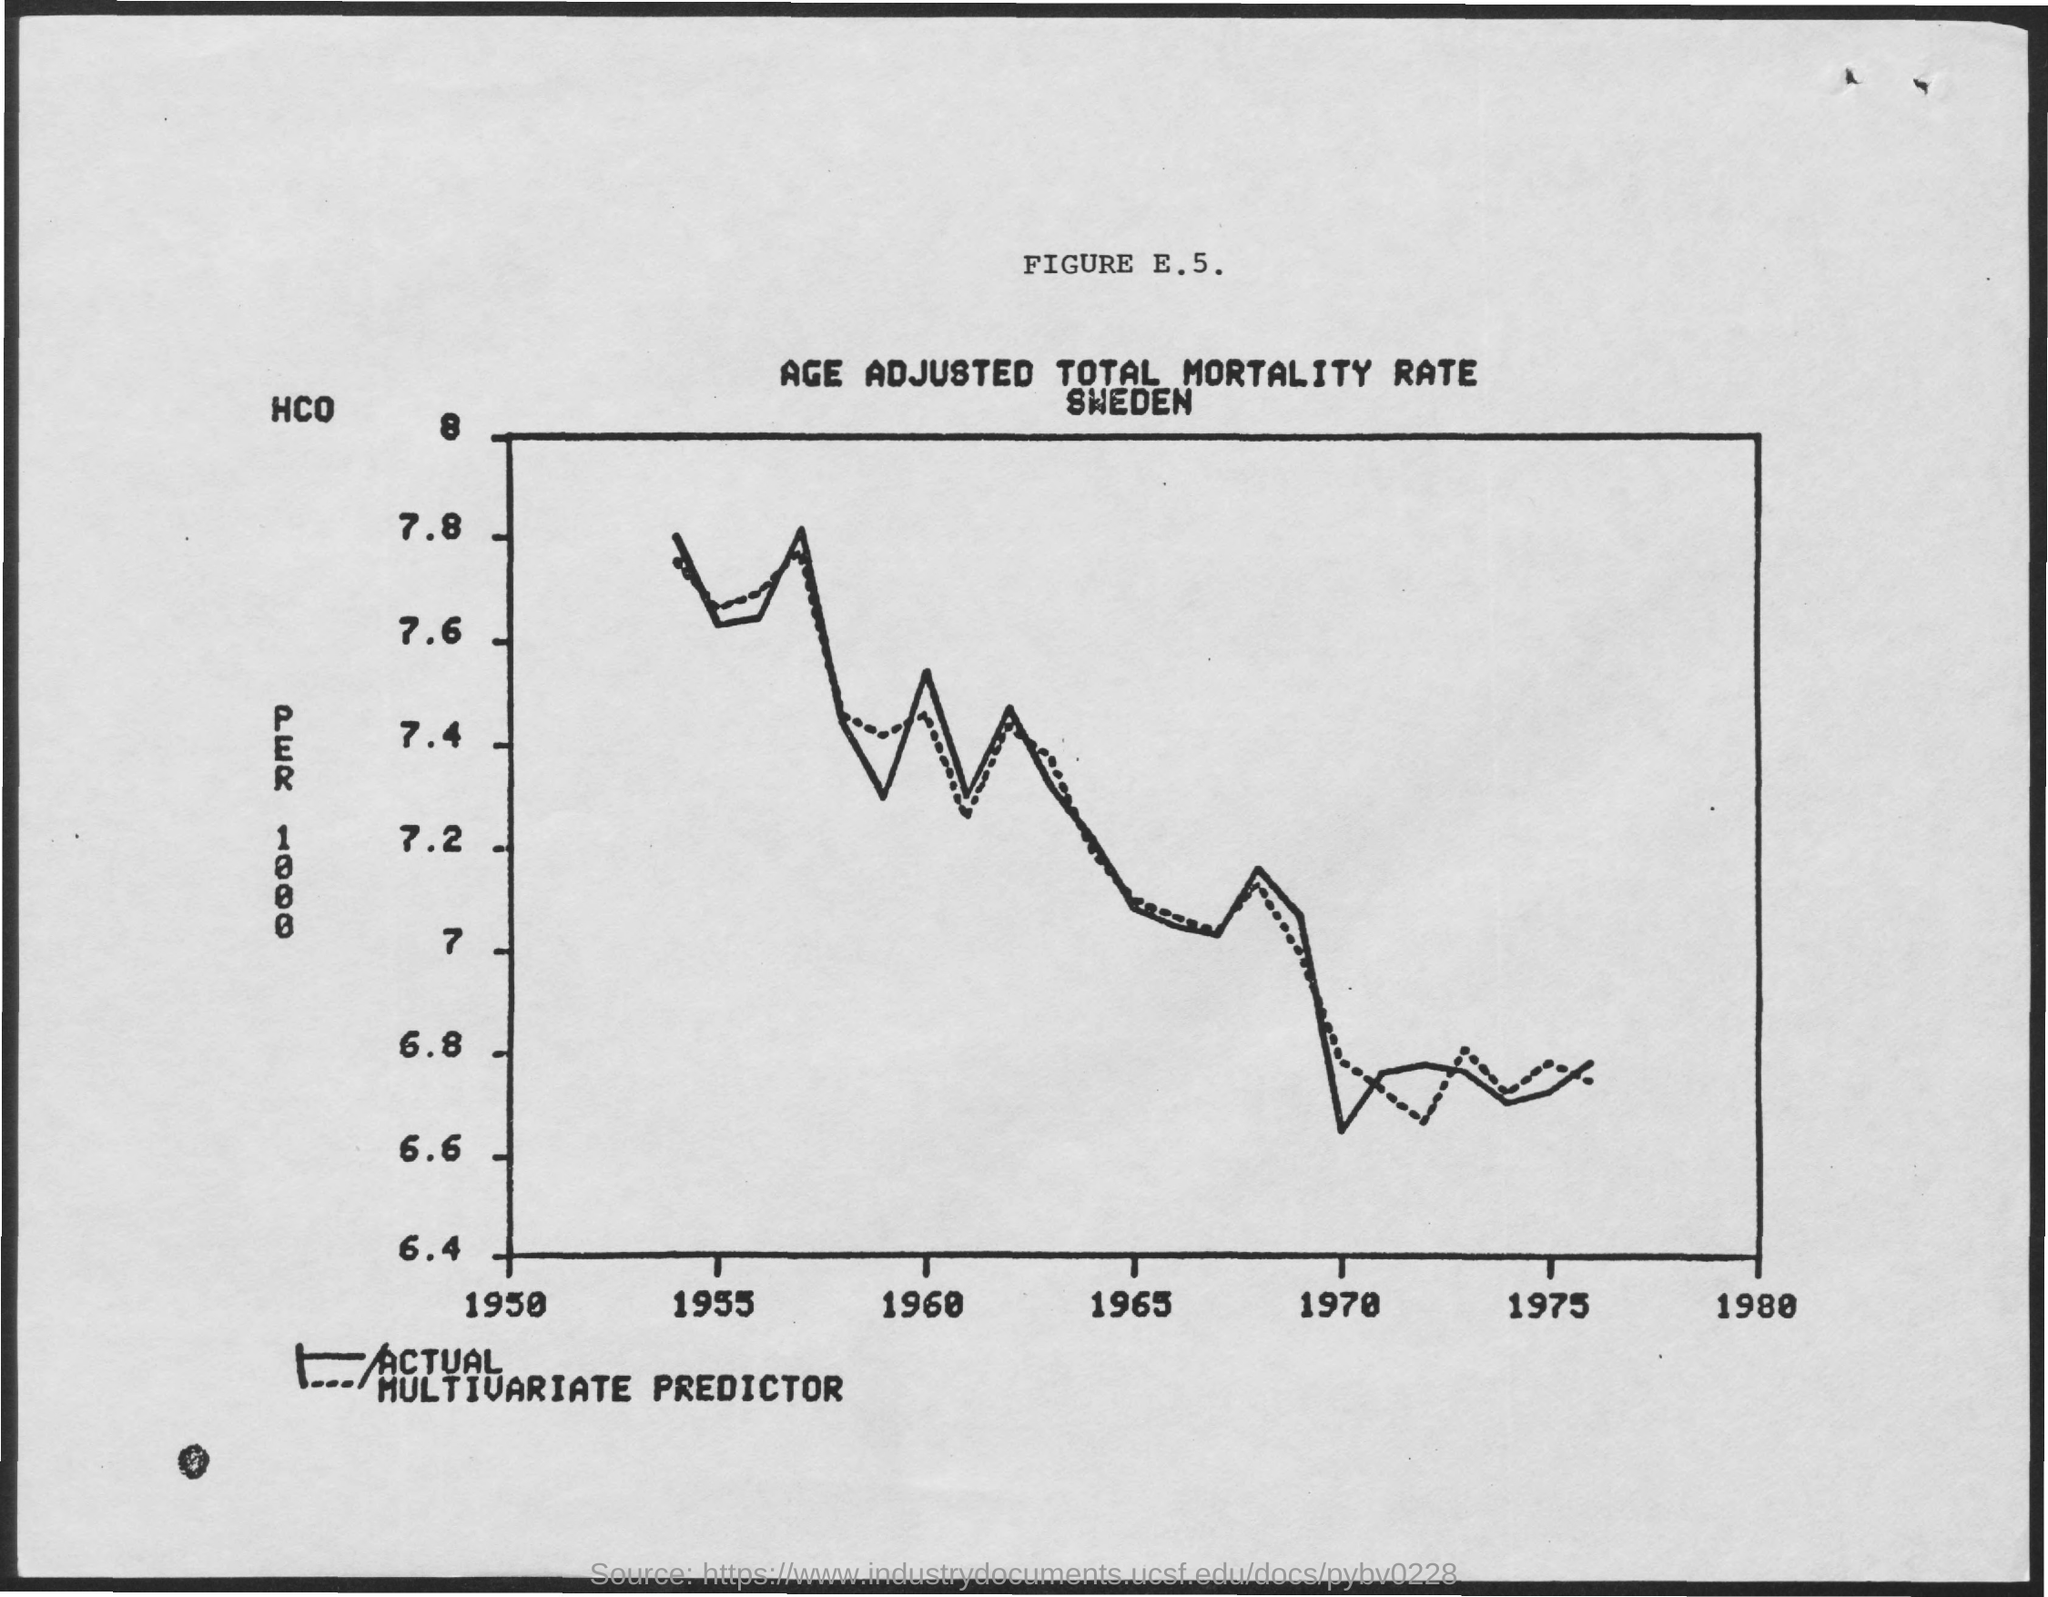What is the title of FIGURE E.5.?
Provide a succinct answer. AGE ADJUSTED TOTAL MORTALITY RATE SWEDEN. 